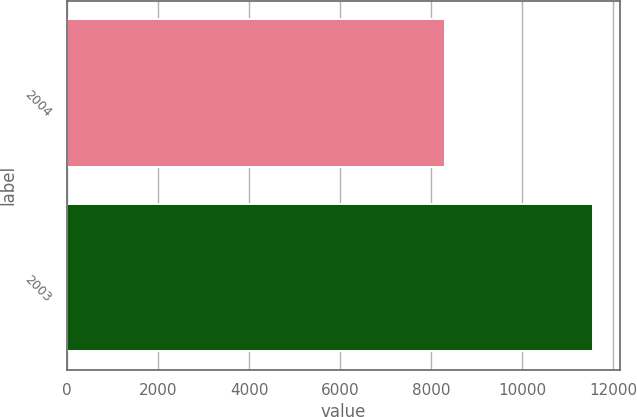Convert chart. <chart><loc_0><loc_0><loc_500><loc_500><bar_chart><fcel>2004<fcel>2003<nl><fcel>8295<fcel>11565<nl></chart> 